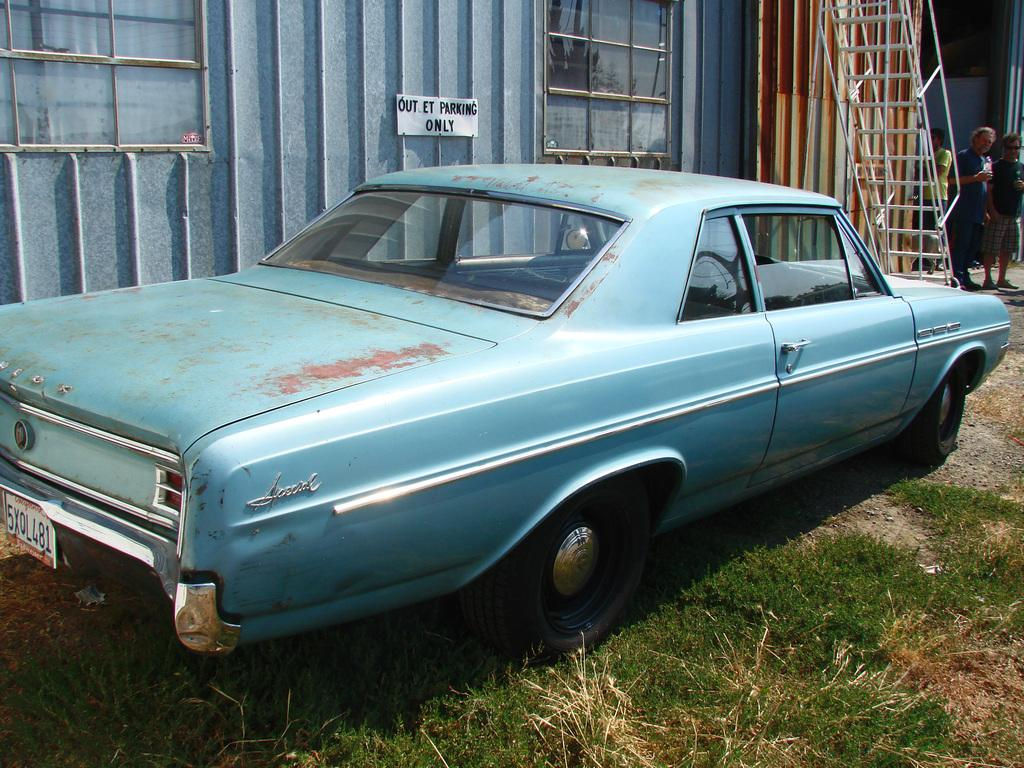What color is the car in the image? The car in the image is blue. Where is the car located in the image? The car is on the grass. What can be seen in the background of the image? There is a shed and a group of people in the background of the image. What features does the shed have? The shed has a paper, windows, and a staircase. What type of bird is flying over the car in the image? There is no bird flying over the car in the image. What color is the light illuminating the car in the image? There is no light illuminating the car in the image. 